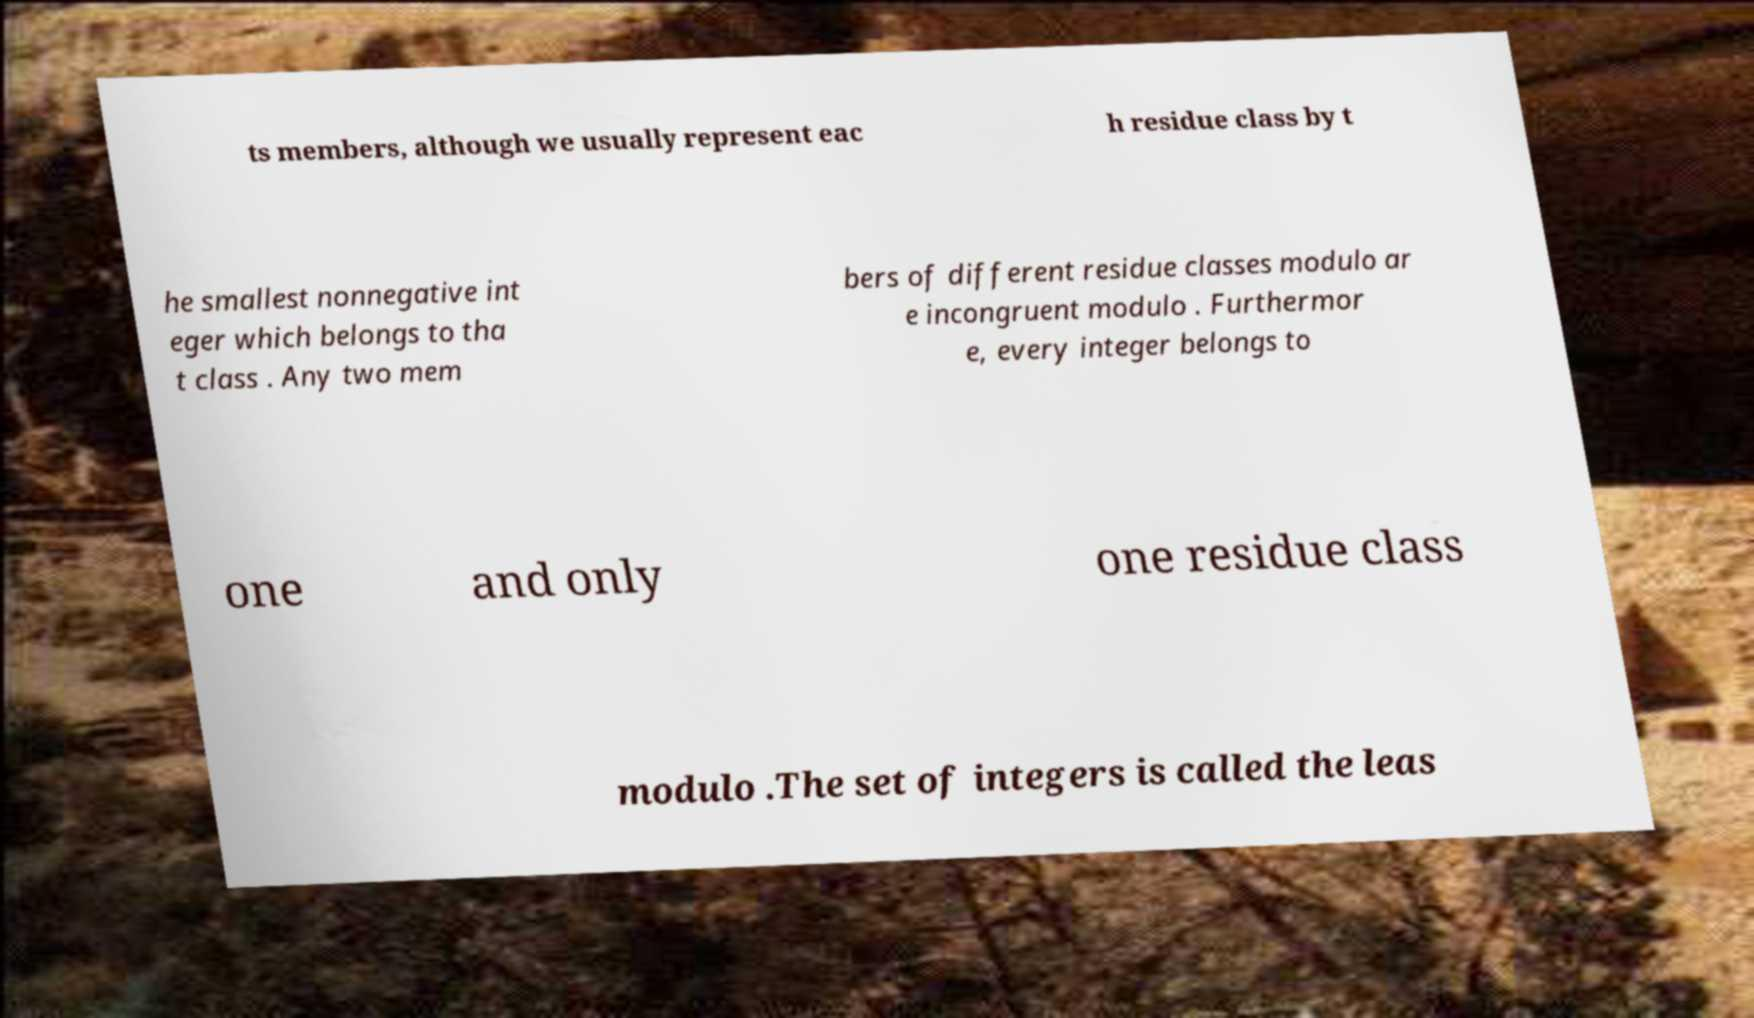Could you assist in decoding the text presented in this image and type it out clearly? ts members, although we usually represent eac h residue class by t he smallest nonnegative int eger which belongs to tha t class . Any two mem bers of different residue classes modulo ar e incongruent modulo . Furthermor e, every integer belongs to one and only one residue class modulo .The set of integers is called the leas 